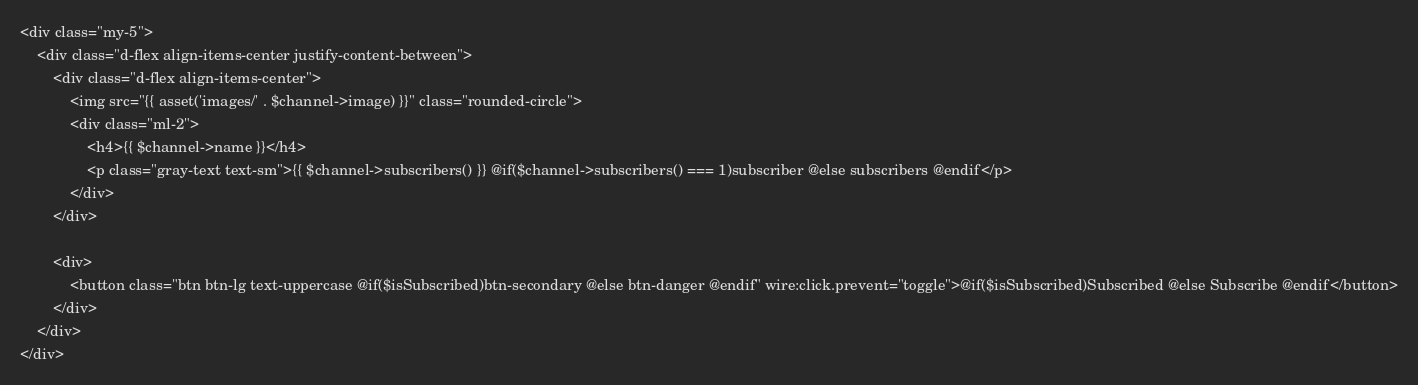Convert code to text. <code><loc_0><loc_0><loc_500><loc_500><_PHP_><div class="my-5">
    <div class="d-flex align-items-center justify-content-between">
        <div class="d-flex align-items-center">
            <img src="{{ asset('images/' . $channel->image) }}" class="rounded-circle">
            <div class="ml-2">
                <h4>{{ $channel->name }}</h4>
                <p class="gray-text text-sm">{{ $channel->subscribers() }} @if($channel->subscribers() === 1)subscriber @else subscribers @endif</p>
            </div>
        </div>

        <div>
            <button class="btn btn-lg text-uppercase @if($isSubscribed)btn-secondary @else btn-danger @endif" wire:click.prevent="toggle">@if($isSubscribed)Subscribed @else Subscribe @endif</button>
        </div>
    </div>
</div>
</code> 